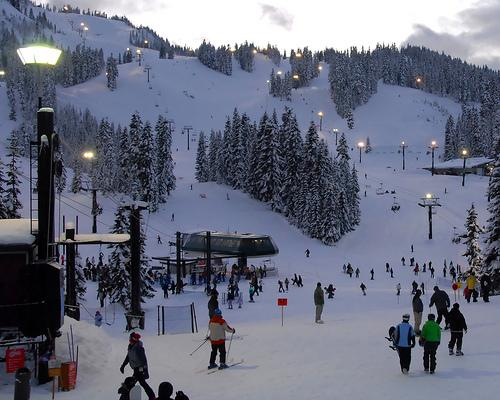What does this scene look most like?

Choices:
A) winter wonderland
B) maypole dance
C) desert
D) seaside villa winter wonderland 